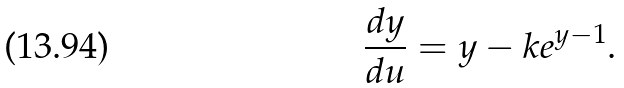Convert formula to latex. <formula><loc_0><loc_0><loc_500><loc_500>\frac { d y } { d u } = y - k e ^ { y - 1 } .</formula> 